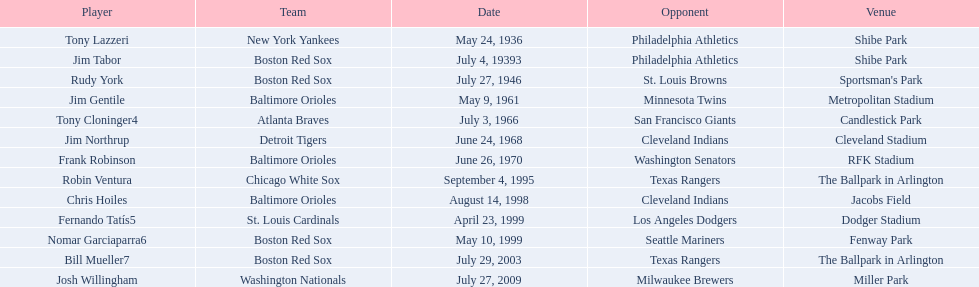Can you provide the names of every player? Tony Lazzeri, Jim Tabor, Rudy York, Jim Gentile, Tony Cloninger4, Jim Northrup, Frank Robinson, Robin Ventura, Chris Hoiles, Fernando Tatís5, Nomar Garciaparra6, Bill Mueller7, Josh Willingham. What are the names of the teams with home run records? New York Yankees, Boston Red Sox, Baltimore Orioles, Atlanta Braves, Detroit Tigers, Chicago White Sox, St. Louis Cardinals, Washington Nationals. Who is the player that played for the new york yankees? Tony Lazzeri. 